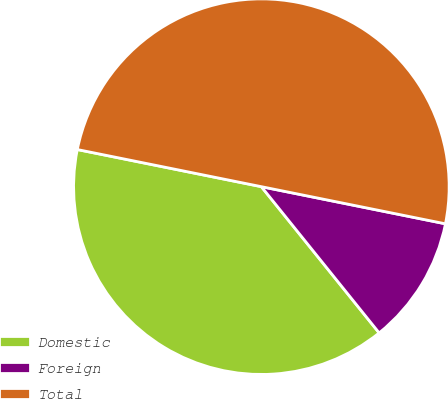Convert chart. <chart><loc_0><loc_0><loc_500><loc_500><pie_chart><fcel>Domestic<fcel>Foreign<fcel>Total<nl><fcel>38.96%<fcel>11.04%<fcel>50.0%<nl></chart> 